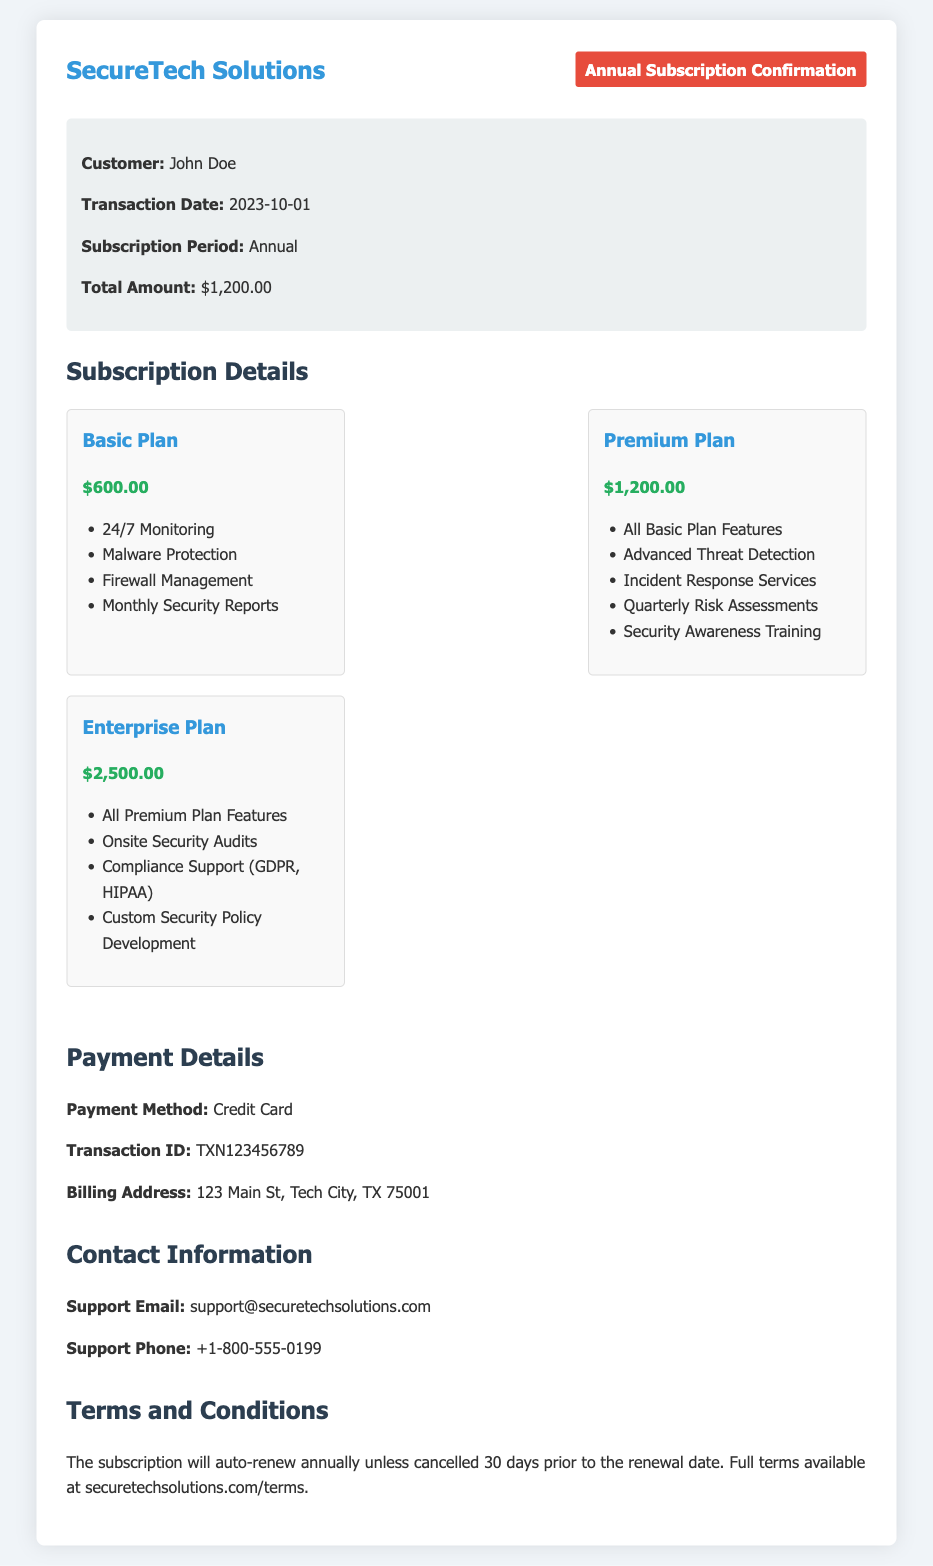What is the customer's name? The customer's name is mentioned in the customer info section of the document.
Answer: John Doe What is the transaction date? The transaction date is specified in the customer info section and represents when the subscription was purchased.
Answer: 2023-10-01 What are the features included in the Basic Plan? The features of the Basic Plan are listed within its section in the document.
Answer: 24/7 Monitoring, Malware Protection, Firewall Management, Monthly Security Reports What is the price of the Premium Plan? The price of the Premium Plan is provided in the subscription details under the plan section.
Answer: $1,200.00 How can the customer cancel the subscription? Cancellation instructions are implied in the terms section regarding the renewal process.
Answer: 30 days prior to the renewal date What is the total amount paid for the subscription? The total amount paid is shown in the customer info section as the total for the subscription.
Answer: $1,200.00 What payment method was used for the transaction? The payment method is listed in the payment info section of the document.
Answer: Credit Card How long is the subscription period? The subscription period is specified in the customer info section of the document.
Answer: Annual What support email is provided for customer inquiries? The support email is given under the contact information section of the document.
Answer: support@securetechsolutions.com 